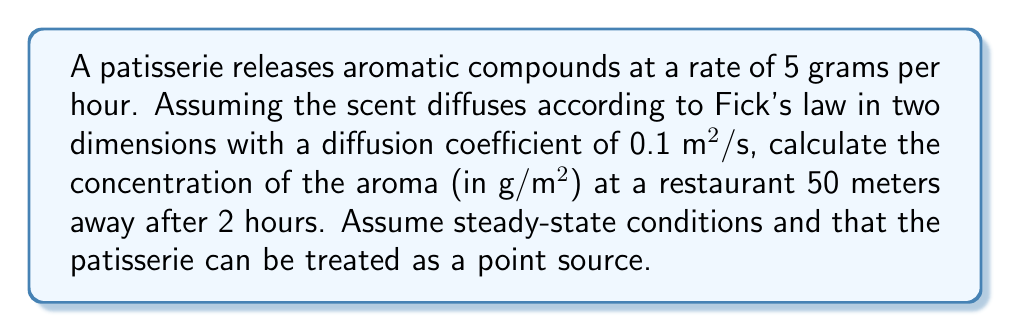Provide a solution to this math problem. To solve this problem, we'll use the steady-state solution to Fick's second law of diffusion in two dimensions. The equation for concentration $C$ at a distance $r$ from a point source with emission rate $Q$ is:

$$ C(r) = \frac{Q}{4\pi D r} $$

Where:
$Q$ = emission rate (g/s)
$D$ = diffusion coefficient (m²/s)
$r$ = distance from source (m)

Step 1: Convert the emission rate to g/s
$Q = 5 \text{ g/hour} = \frac{5}{3600} \text{ g/s} \approx 0.00139 \text{ g/s}$

Step 2: Use the given values
$D = 0.1 \text{ m²/s}$
$r = 50 \text{ m}$

Step 3: Substitute into the equation
$$ C(50) = \frac{0.00139}{4\pi \cdot 0.1 \cdot 50} $$

Step 4: Calculate the result
$$ C(50) \approx 2.21 \times 10^{-6} \text{ g/m²} $$

Note: The time (2 hours) is not directly used in the calculation because we assumed steady-state conditions, which implies that the concentration has reached equilibrium.
Answer: $2.21 \times 10^{-6} \text{ g/m²}$ 